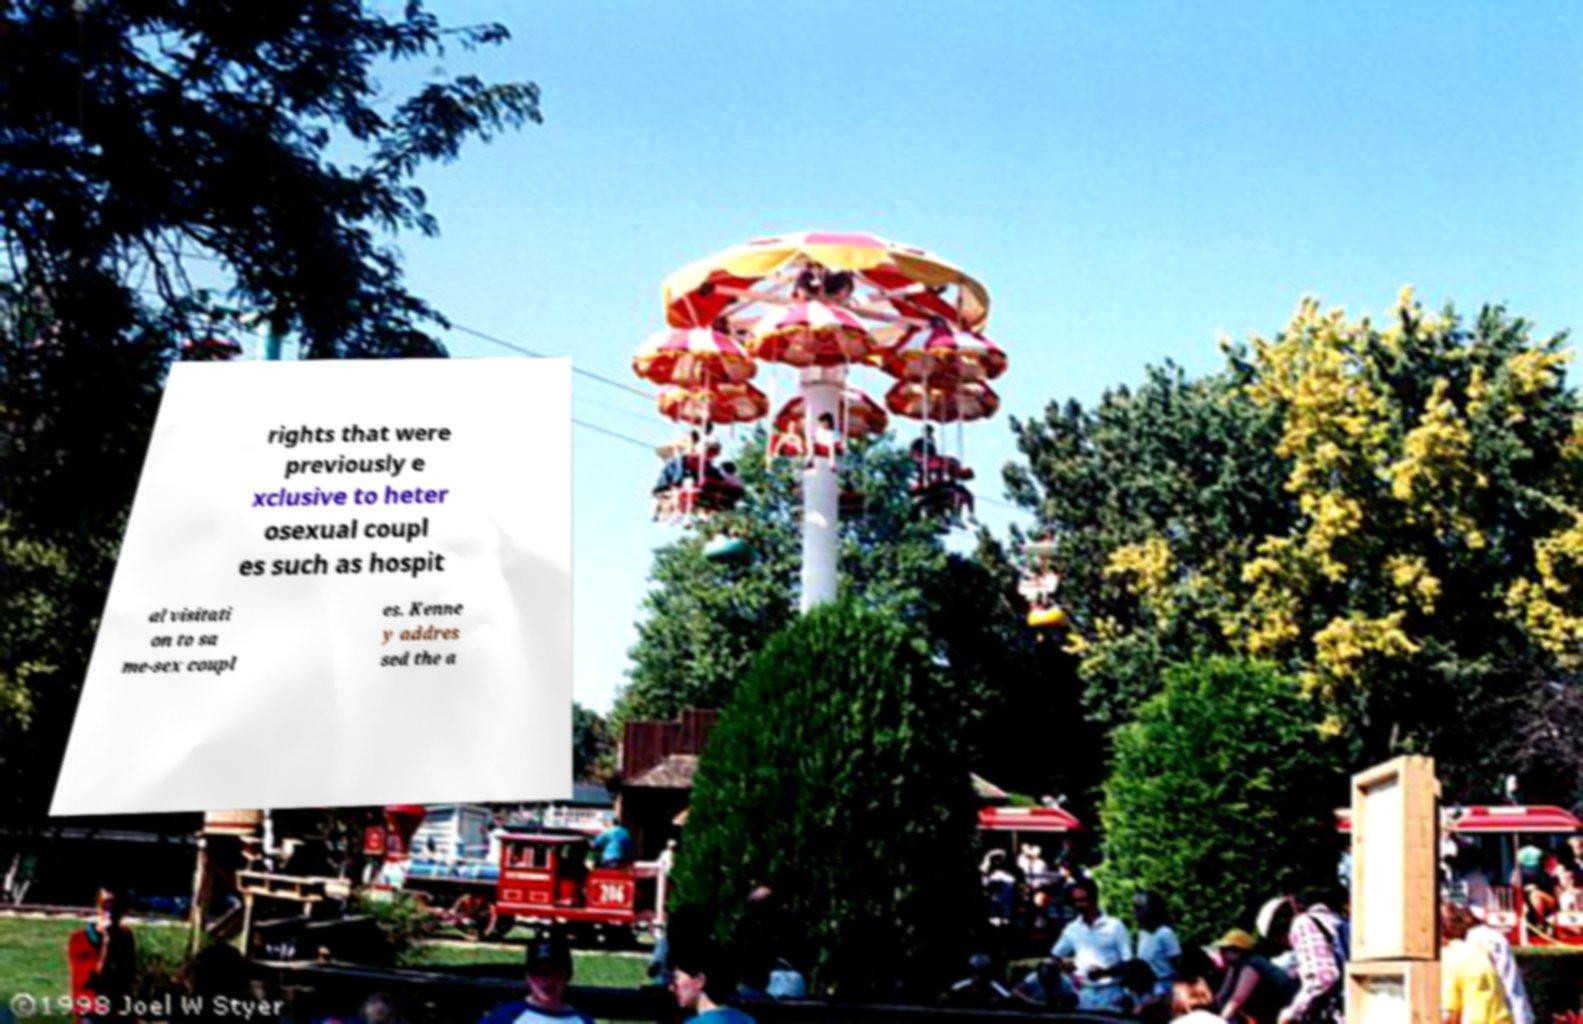Please read and relay the text visible in this image. What does it say? rights that were previously e xclusive to heter osexual coupl es such as hospit al visitati on to sa me-sex coupl es. Kenne y addres sed the a 